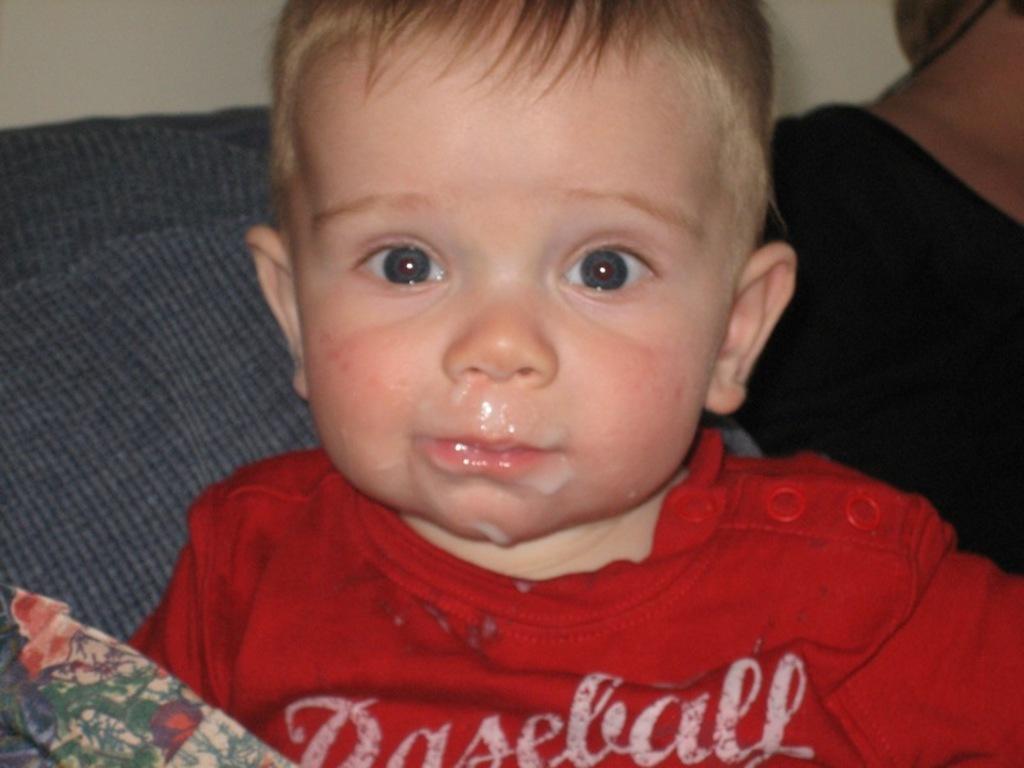Please provide a concise description of this image. In this picture there is a boy who is wearing red t-shirt and he is sitting on the couch. Back Side we can see a women who is wearing black t-shirt and sitting near to the wall. 